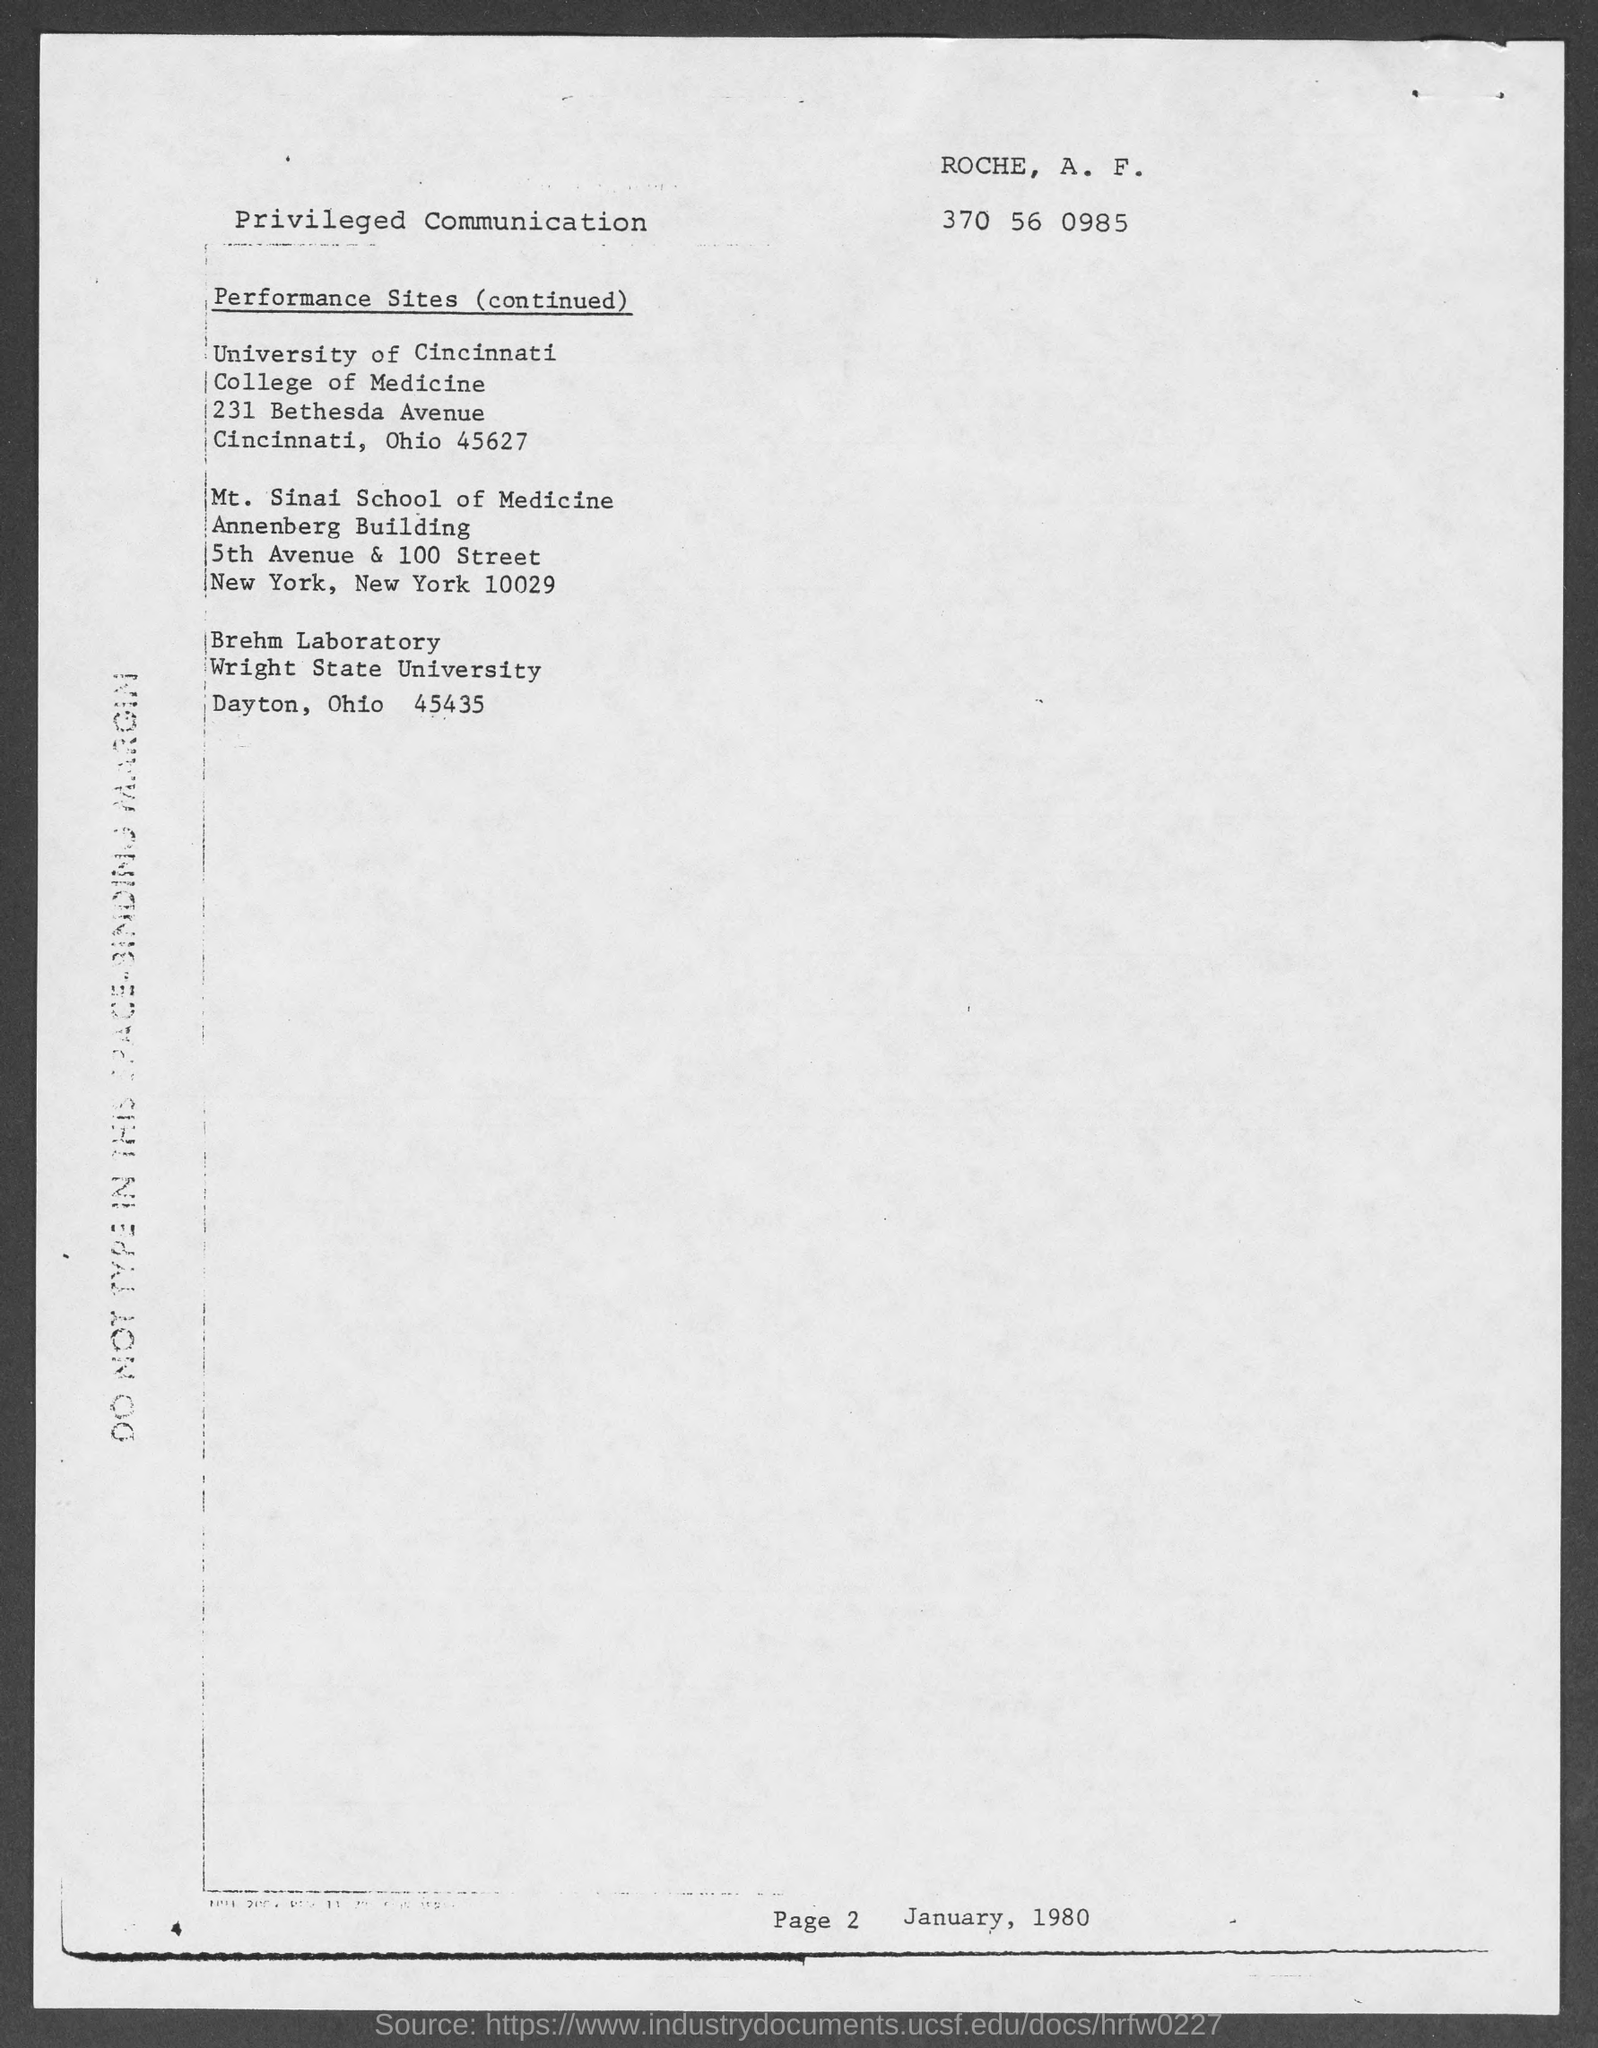Point out several critical features in this image. The Mount Sinai School of Medicine is located in the Annenberg building. 